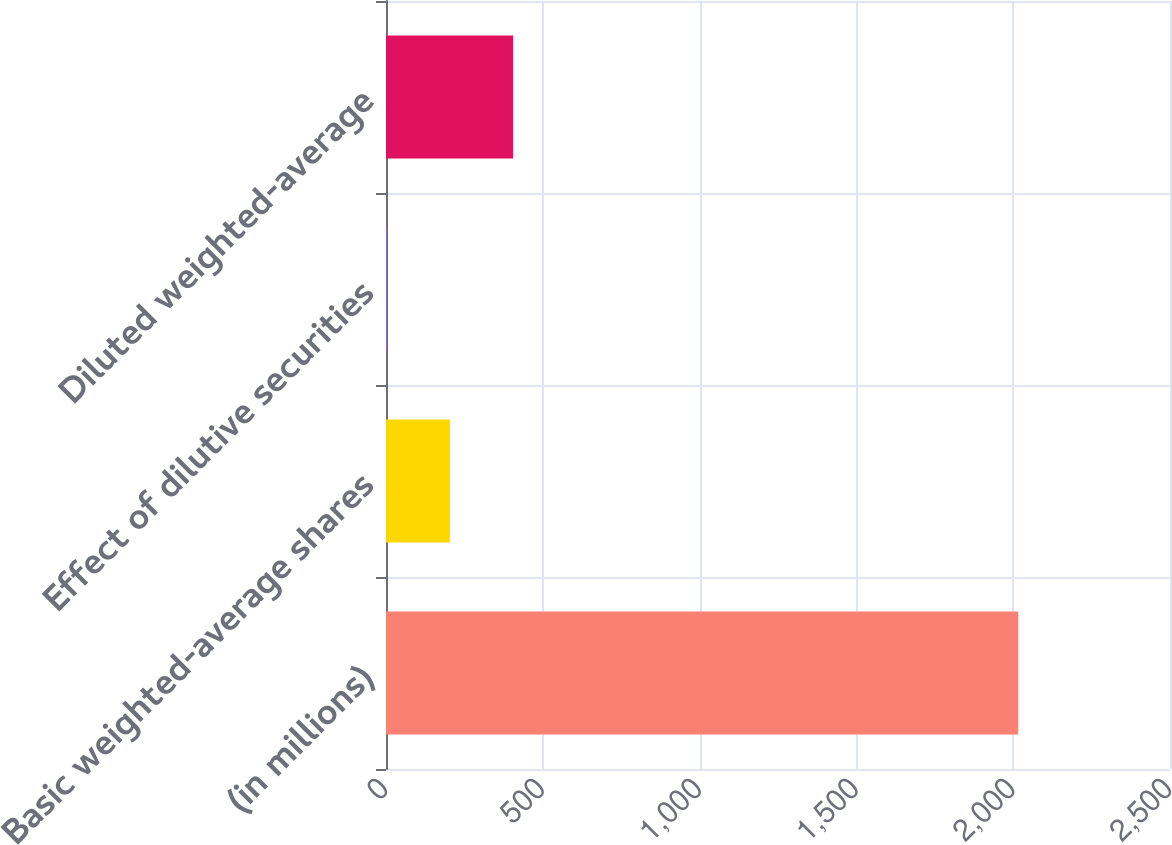Convert chart to OTSL. <chart><loc_0><loc_0><loc_500><loc_500><bar_chart><fcel>(in millions)<fcel>Basic weighted-average shares<fcel>Effect of dilutive securities<fcel>Diluted weighted-average<nl><fcel>2016<fcel>203.76<fcel>2.4<fcel>405.12<nl></chart> 